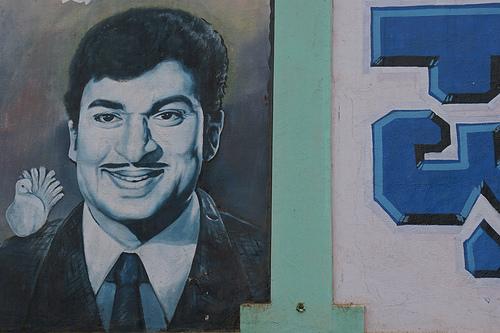Is this guy a celebrity?
Be succinct. No. Is this an old painting?
Concise answer only. Yes. What is the black mark above the man's lip?
Concise answer only. Mustache. 